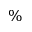<formula> <loc_0><loc_0><loc_500><loc_500>\%</formula> 